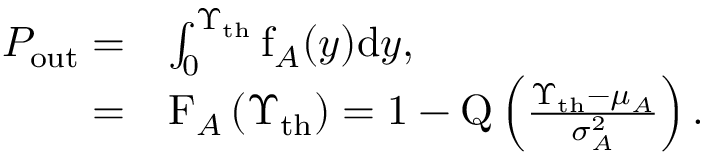<formula> <loc_0><loc_0><loc_500><loc_500>\begin{array} { r l } { P _ { o u t } = } & { \int _ { 0 } ^ { \Upsilon _ { t h } } f _ { A } ( y ) d y , } \\ { = } & { F _ { A } \left ( \Upsilon _ { t h } \right ) = 1 - Q \left ( \frac { \Upsilon _ { t h } - \mu _ { A } } { \sigma _ { A } ^ { 2 } } \right ) . } \end{array}</formula> 